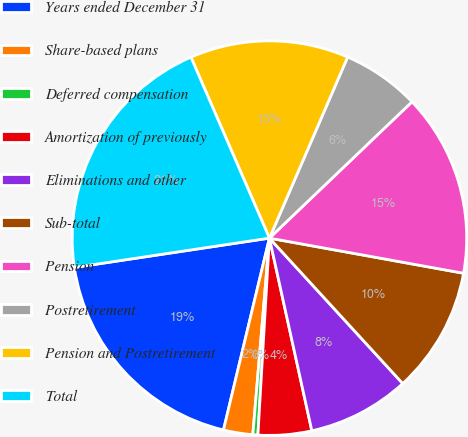Convert chart to OTSL. <chart><loc_0><loc_0><loc_500><loc_500><pie_chart><fcel>Years ended December 31<fcel>Share-based plans<fcel>Deferred compensation<fcel>Amortization of previously<fcel>Eliminations and other<fcel>Sub-total<fcel>Pension<fcel>Postretirement<fcel>Pension and Postretirement<fcel>Total<nl><fcel>18.88%<fcel>2.4%<fcel>0.41%<fcel>4.38%<fcel>8.36%<fcel>10.34%<fcel>14.99%<fcel>6.37%<fcel>13.0%<fcel>20.86%<nl></chart> 